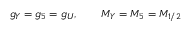<formula> <loc_0><loc_0><loc_500><loc_500>g _ { Y } = g _ { 5 } = g _ { U } , \quad M _ { Y } = M _ { 5 } = M _ { 1 / 2 }</formula> 